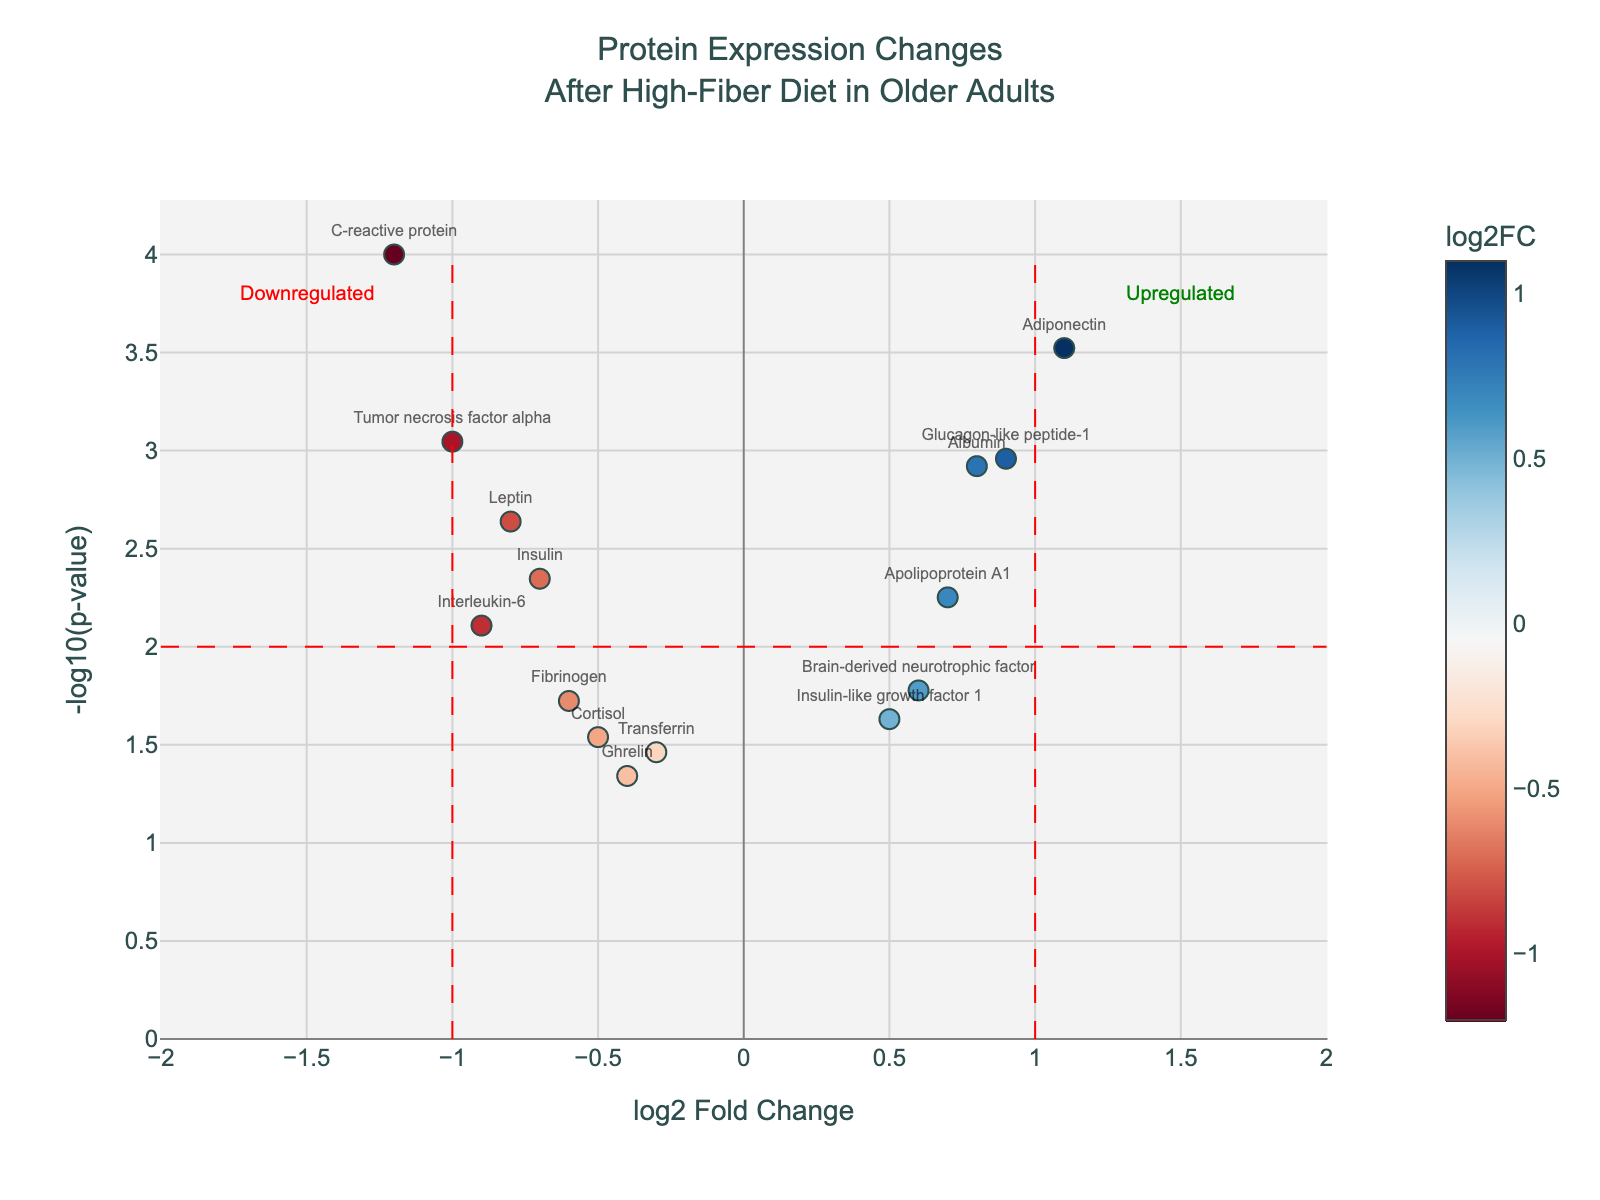What is the title of the plot? The title is located at the top center of the plot and it reads: "Protein Expression Changes After High-Fiber Diet in Older Adults".
Answer: Protein Expression Changes After High-Fiber Diet in Older Adults How many proteins have a log2 fold change greater than 1? By looking at the x-axis of the plot, count the markers that fall to the right of x = 1 threshold line. There are two such proteins: Adiponectin and Glucagon-like peptide-1.
Answer: 2 Which protein shows the most significant increase in expression? The protein with the highest -log10(p-value) and a positive log2FoldChange indicates the most significant increase. Adiponectin is located at the highest point in the plot and has a positive log2FoldChange.
Answer: Adiponectin Which proteins have a log2 fold change between -1 and 1 and a -log10(p-value) greater than 2? Identify proteins within the x-axis range of -1 to 1 and vertically above y = 2 line. These proteins are: Albumin, Apolipoprotein A1, and Glucagon-like peptide-1.
Answer: Albumin, Apolipoprotein A1, Glucagon-like peptide-1 How many proteins show a significant decrease in expression with p-value less than 0.01? Proteins with a negative log2FoldChange and corresponding -log10(p-value) higher than 2 (which equates to p-value < 0.01) indicate significant decrease. These proteins are: C-reactive protein, Interleukin-6, Tumor necrosis factor alpha, and Insulin.
Answer: 4 Which protein has the lowest log2 fold change and what is its significance level? The protein with the lowest log2FoldChange (most negative value) is C-reactive protein with log2FoldChange of -1.2. Its significance level is p-value, visible in hovertext or based on -log10(p-value).
Answer: C-reactive protein with p-value 0.0001 How does Leptin's expression change after the high-fiber diet in terms of log2 fold change and p-value? Locate Leptin in the plot using the hovertext or marker labeling. Leptin has a log2FoldChange of -0.8 and a p-value of 0.0023.
Answer: log2FoldChange: -0.8, p-value: 0.0023 Compare the significance levels of Albumin and Insulin-like growth factor 1. Which one is more significant? Compare their -log10(p-value) values obtained from the y-axis. Albumin has a -log10(p-value) of about 2.9, while Insulin-like growth factor 1 has about 1.6. Higher means more significant.
Answer: Albumin Which proteins show a significant change (p-value < 0.01) but remain within the  log2 fold change range of -1 to 1? Proteins with a -log10(p-value) above 2 (p-value < 0.01) and residing within the x-range of -1 to 1 are Albumin, Apolipoprotein A1, and Insulin-like growth factor 1.
Answer: Albumin, Apolipoprotein A1, Insulin-like growth factor 1 What does the -log10(p-value) axis represent and how does it help identify significant changes? The -log10(p-value) axis represents the significance of the expression changes. A higher -log10(p-value) corresponds to a lower p-value and thus more significant changes. Points higher on this axis indicate proteins with more statistically significant expression changes.
Answer: Higher -log10(p-value) indicates more significant changes 